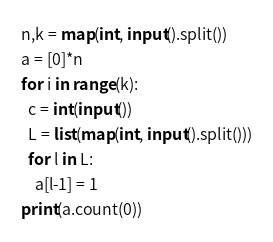Convert code to text. <code><loc_0><loc_0><loc_500><loc_500><_Python_>n,k = map(int, input().split())
a = [0]*n
for i in range(k):
  c = int(input())
  L = list(map(int, input().split()))
  for l in L:
    a[l-1] = 1
print(a.count(0))</code> 